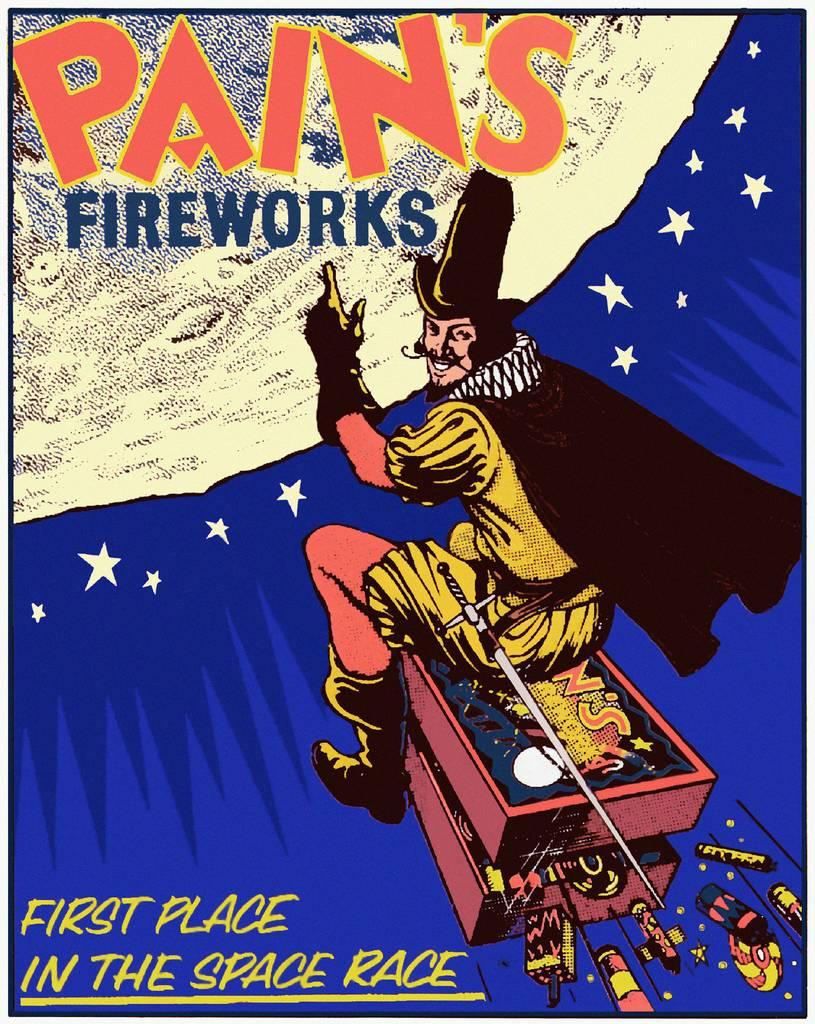<image>
Present a compact description of the photo's key features. An advertisement for Pain's Fireworks that shows a man riding towards the moon. 